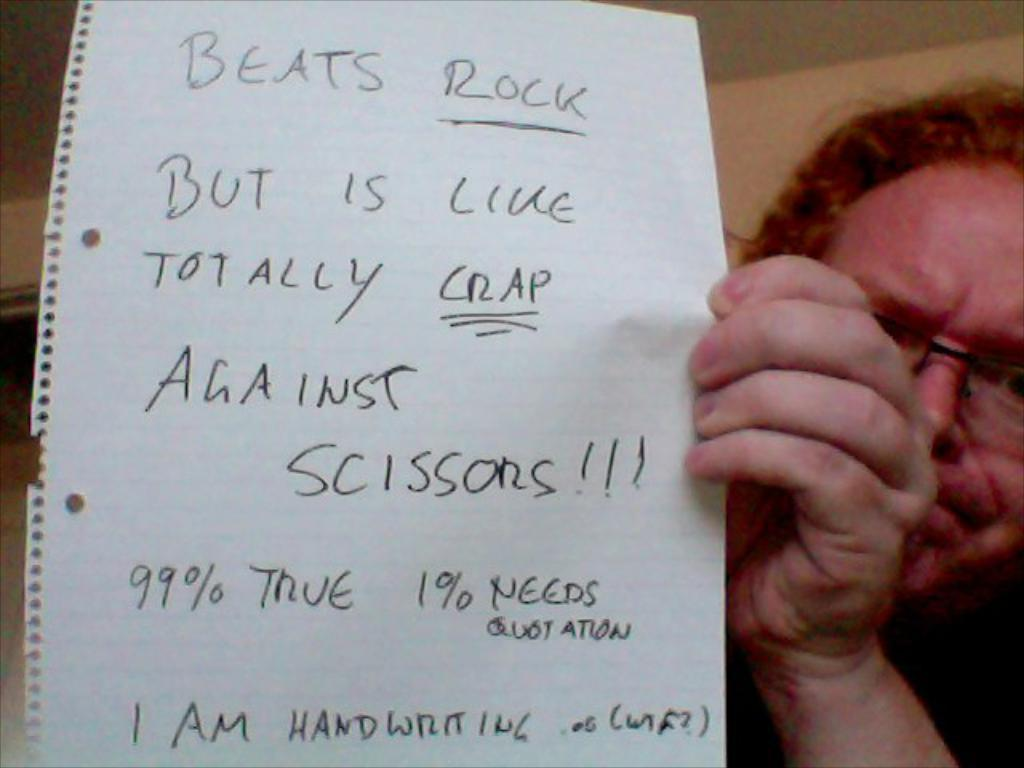Who is present in the image? There is a man in the image. What is the man holding in the image? The man is holding a paper. What can be seen on the paper? There is writing on the paper. What type of cap is the man wearing in the image? There is no cap visible in the image; the man is not wearing a cap. 